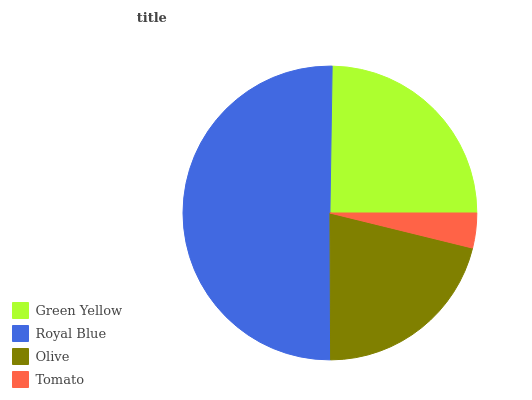Is Tomato the minimum?
Answer yes or no. Yes. Is Royal Blue the maximum?
Answer yes or no. Yes. Is Olive the minimum?
Answer yes or no. No. Is Olive the maximum?
Answer yes or no. No. Is Royal Blue greater than Olive?
Answer yes or no. Yes. Is Olive less than Royal Blue?
Answer yes or no. Yes. Is Olive greater than Royal Blue?
Answer yes or no. No. Is Royal Blue less than Olive?
Answer yes or no. No. Is Green Yellow the high median?
Answer yes or no. Yes. Is Olive the low median?
Answer yes or no. Yes. Is Tomato the high median?
Answer yes or no. No. Is Royal Blue the low median?
Answer yes or no. No. 